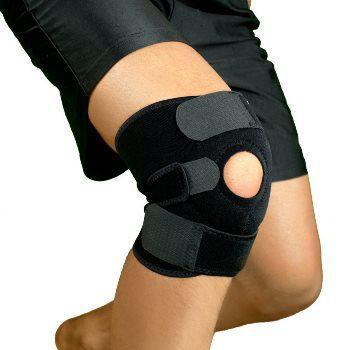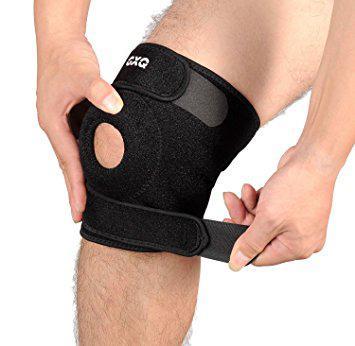The first image is the image on the left, the second image is the image on the right. Evaluate the accuracy of this statement regarding the images: "One black kneepad with a round knee hole is in each image, one of them being adjusted by a person using two hands.". Is it true? Answer yes or no. Yes. 